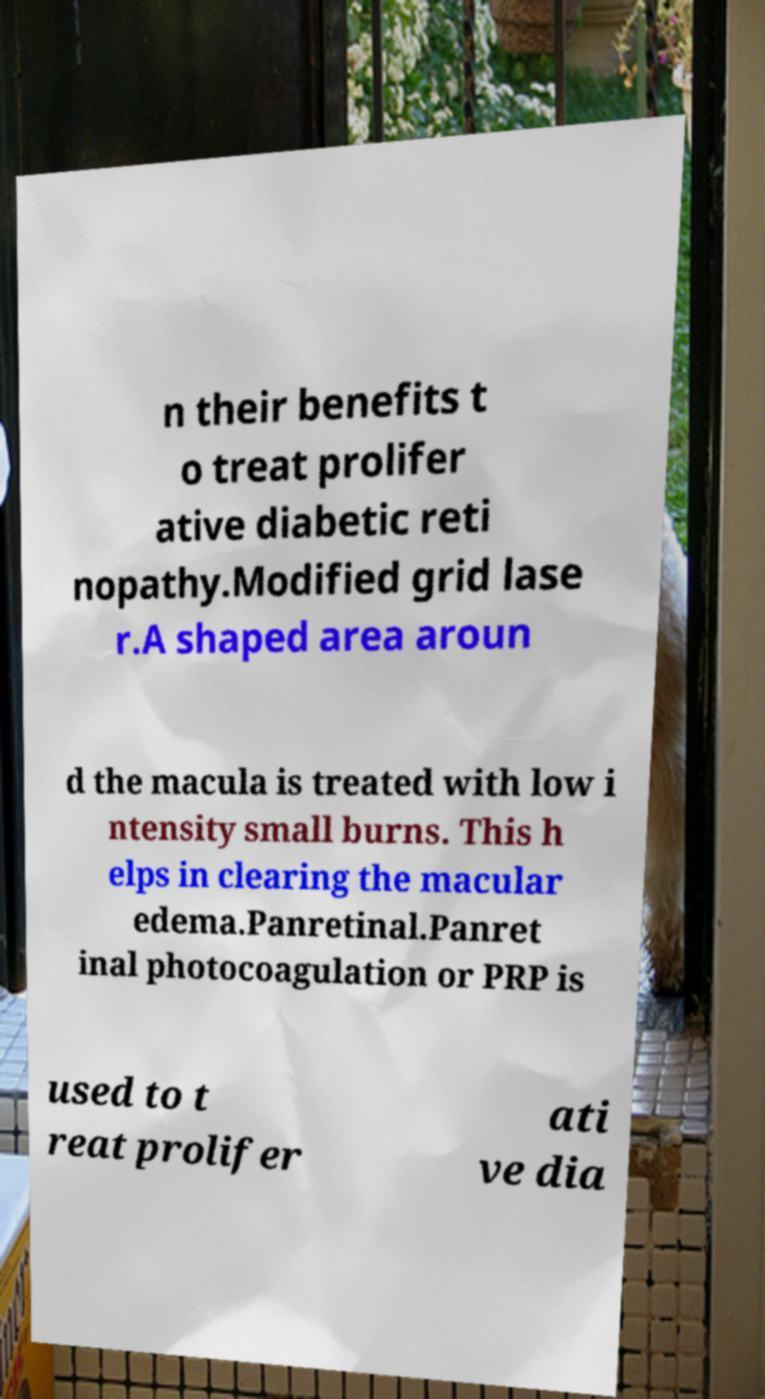Please identify and transcribe the text found in this image. n their benefits t o treat prolifer ative diabetic reti nopathy.Modified grid lase r.A shaped area aroun d the macula is treated with low i ntensity small burns. This h elps in clearing the macular edema.Panretinal.Panret inal photocoagulation or PRP is used to t reat prolifer ati ve dia 